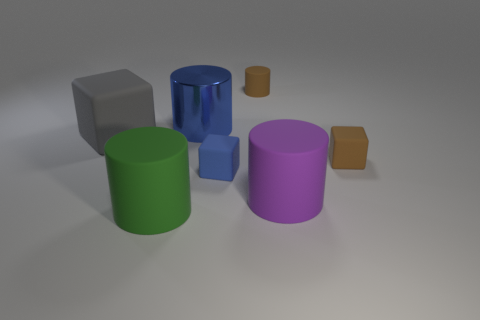Add 1 large cylinders. How many objects exist? 8 Subtract all cylinders. How many objects are left? 3 Add 7 tiny brown rubber cylinders. How many tiny brown rubber cylinders are left? 8 Add 1 small red metallic things. How many small red metallic things exist? 1 Subtract 0 purple balls. How many objects are left? 7 Subtract all small brown cubes. Subtract all tiny blue blocks. How many objects are left? 5 